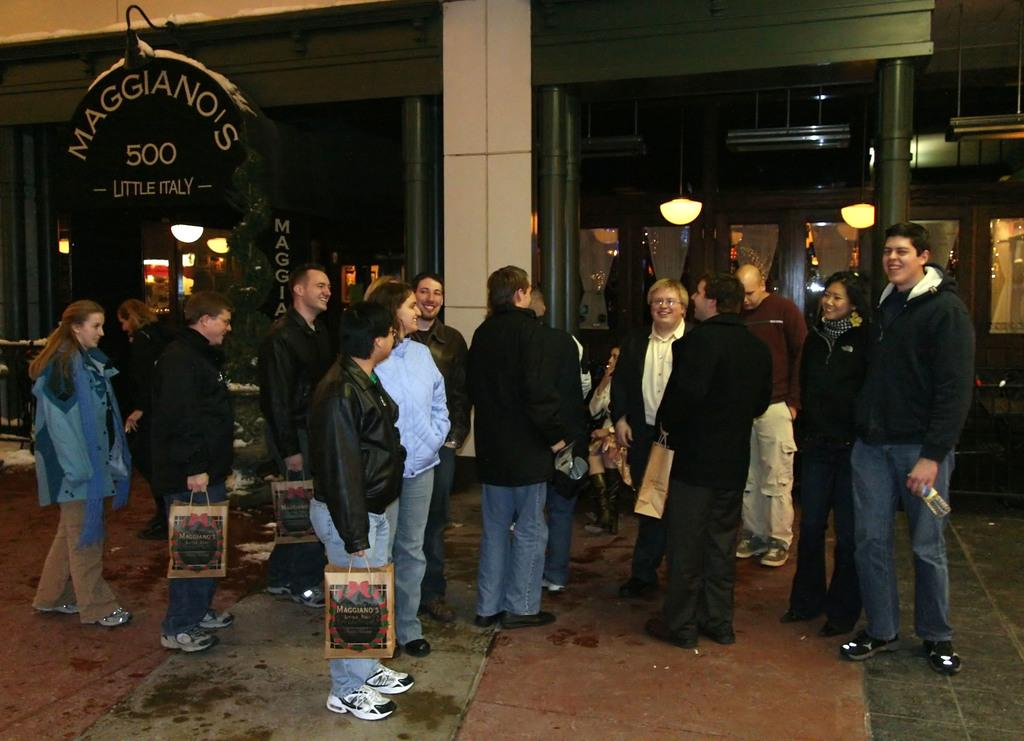Who or what can be seen in the image? There are people in the image. What are some of the people doing in the image? Some of the people are holding packages. Can you describe the house in the image? The house has windows and pillars. What else can be seen in the image besides the people and the house? There are lights visible in the image, and there is a board with text. How does the twist in the image affect the mind of the people? There is no twist present in the image, so it cannot affect the mind of the people. 